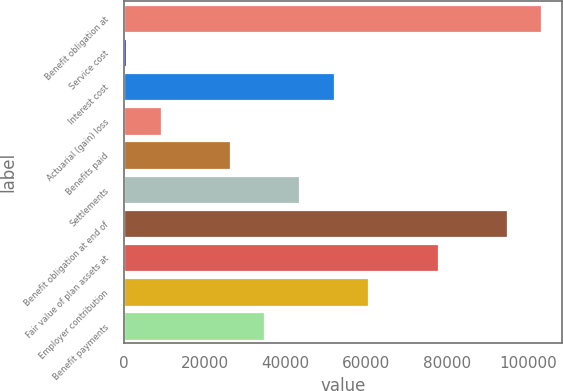Convert chart to OTSL. <chart><loc_0><loc_0><loc_500><loc_500><bar_chart><fcel>Benefit obligation at<fcel>Service cost<fcel>Interest cost<fcel>Actuarial (gain) loss<fcel>Benefits paid<fcel>Settlements<fcel>Benefit obligation at end of<fcel>Fair value of plan assets at<fcel>Employer contribution<fcel>Benefit payments<nl><fcel>103349<fcel>487<fcel>51917.8<fcel>9058.8<fcel>26202.4<fcel>43346<fcel>94776.8<fcel>77633.2<fcel>60489.6<fcel>34774.2<nl></chart> 